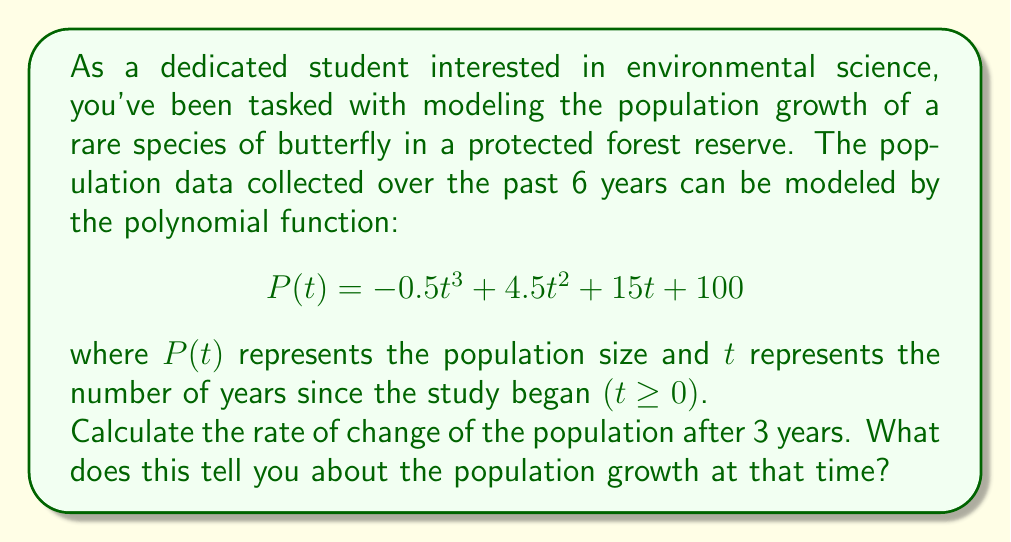Help me with this question. To solve this problem, we need to follow these steps:

1) The rate of change of the population is given by the first derivative of the function $P(t)$.

2) Let's find $P'(t)$ using the power rule:
   $$P'(t) = -1.5t^2 + 9t + 15$$

3) To find the rate of change after 3 years, we need to evaluate $P'(3)$:
   
   $$P'(3) = -1.5(3)^2 + 9(3) + 15$$
   $$= -1.5(9) + 27 + 15$$
   $$= -13.5 + 27 + 15$$
   $$= 28.5$$

4) Interpreting the result:
   - The rate of change is positive, which means the population is increasing.
   - The value 28.5 represents the instantaneous rate of change in population per year at $t = 3$.
   - This means that after 3 years, the population is growing at a rate of 28.5 butterflies per year.

This positive rate of change indicates that the conservation efforts in the forest reserve are likely successful, as the butterfly population is growing rather than declining at this point in time.
Answer: The rate of change of the population after 3 years is 28.5 butterflies per year. This indicates that the population is growing at that time. 